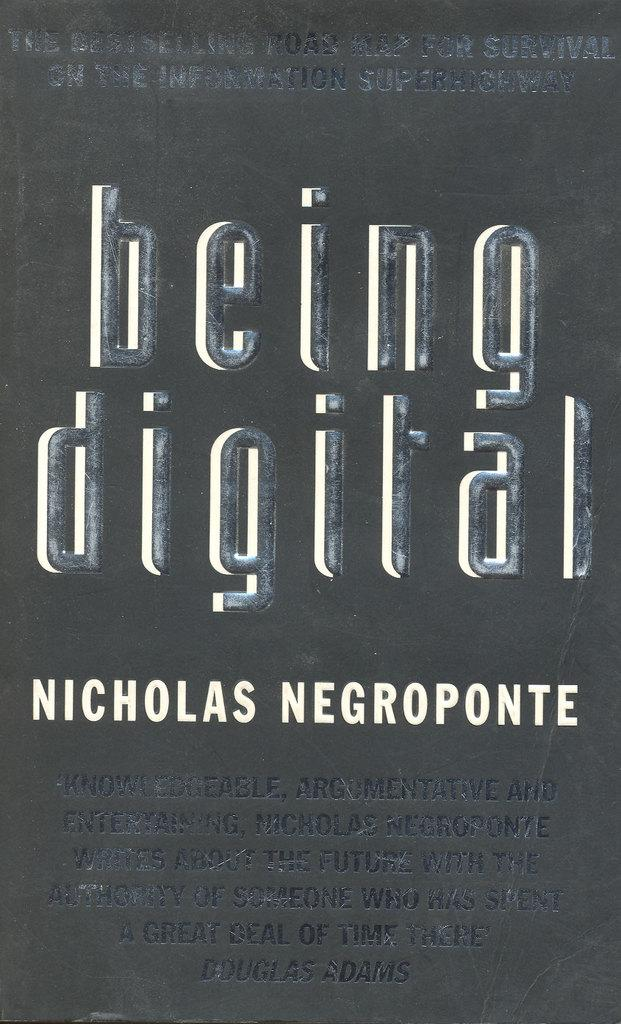<image>
Write a terse but informative summary of the picture. The book Being Digital by Nicholas Negroponte has a black book cover with embossing. 